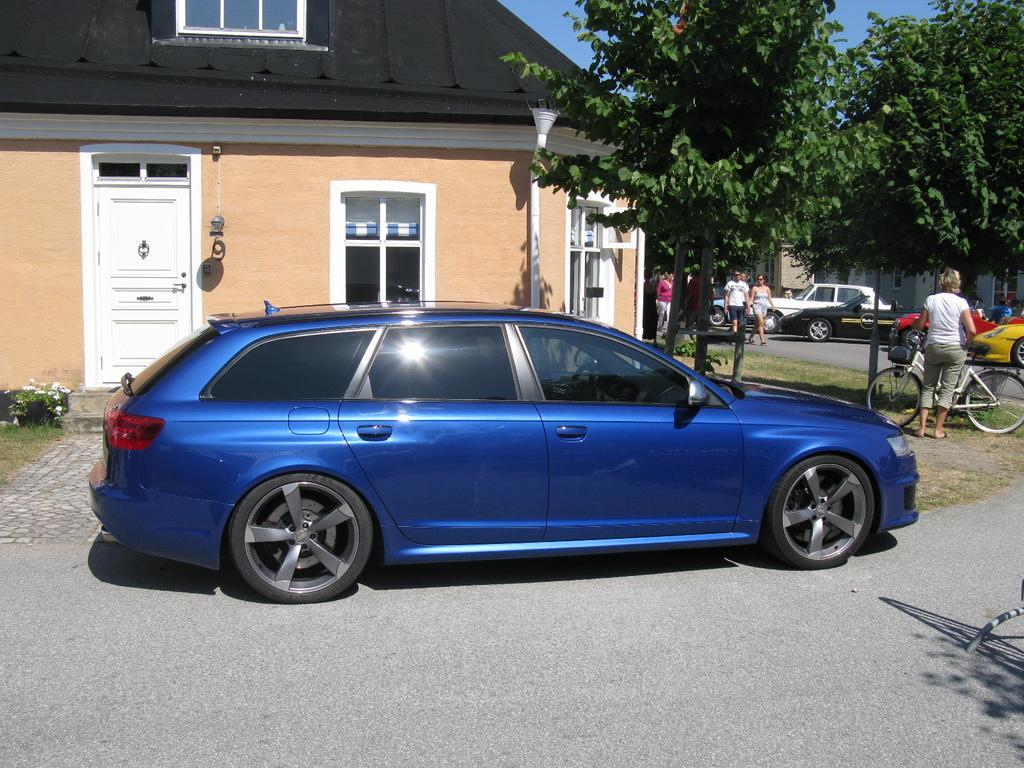How would you summarize this image in a sentence or two? In this image we can see few houses and plants. There are many vehicles in the image. There are flowers to the plant at the left side of the image. There is a lamp in the image. There are few objects on the wall. There is a blue sky in the image. 